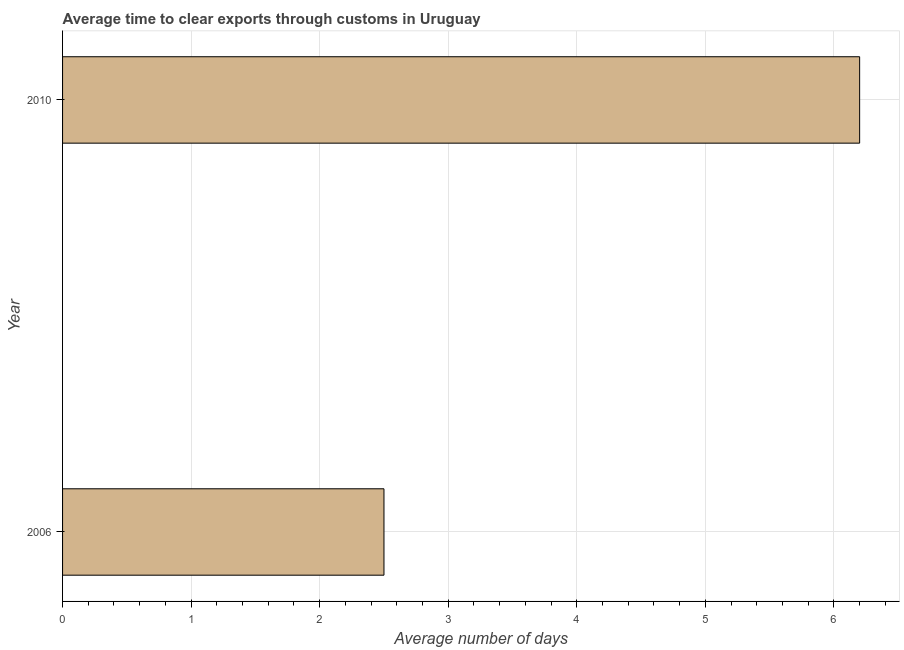Does the graph contain grids?
Your response must be concise. Yes. What is the title of the graph?
Your answer should be very brief. Average time to clear exports through customs in Uruguay. What is the label or title of the X-axis?
Offer a very short reply. Average number of days. Across all years, what is the minimum time to clear exports through customs?
Ensure brevity in your answer.  2.5. In which year was the time to clear exports through customs maximum?
Provide a short and direct response. 2010. In which year was the time to clear exports through customs minimum?
Your answer should be compact. 2006. What is the sum of the time to clear exports through customs?
Provide a succinct answer. 8.7. What is the difference between the time to clear exports through customs in 2006 and 2010?
Ensure brevity in your answer.  -3.7. What is the average time to clear exports through customs per year?
Ensure brevity in your answer.  4.35. What is the median time to clear exports through customs?
Offer a very short reply. 4.35. In how many years, is the time to clear exports through customs greater than 3.4 days?
Offer a terse response. 1. What is the ratio of the time to clear exports through customs in 2006 to that in 2010?
Provide a succinct answer. 0.4. Is the time to clear exports through customs in 2006 less than that in 2010?
Provide a succinct answer. Yes. In how many years, is the time to clear exports through customs greater than the average time to clear exports through customs taken over all years?
Ensure brevity in your answer.  1. How many years are there in the graph?
Your answer should be compact. 2. Are the values on the major ticks of X-axis written in scientific E-notation?
Offer a very short reply. No. What is the difference between the Average number of days in 2006 and 2010?
Provide a short and direct response. -3.7. What is the ratio of the Average number of days in 2006 to that in 2010?
Provide a short and direct response. 0.4. 